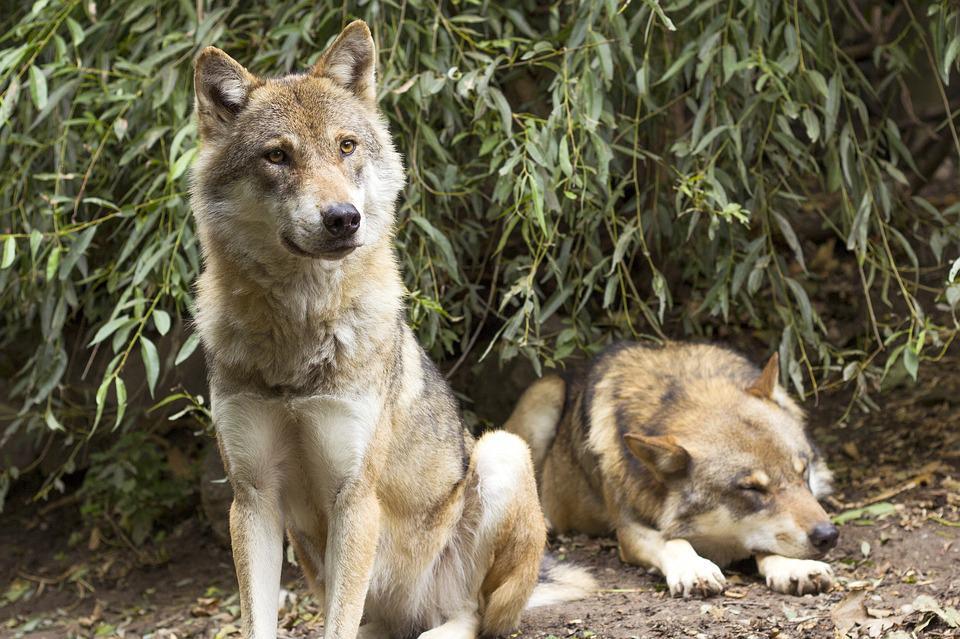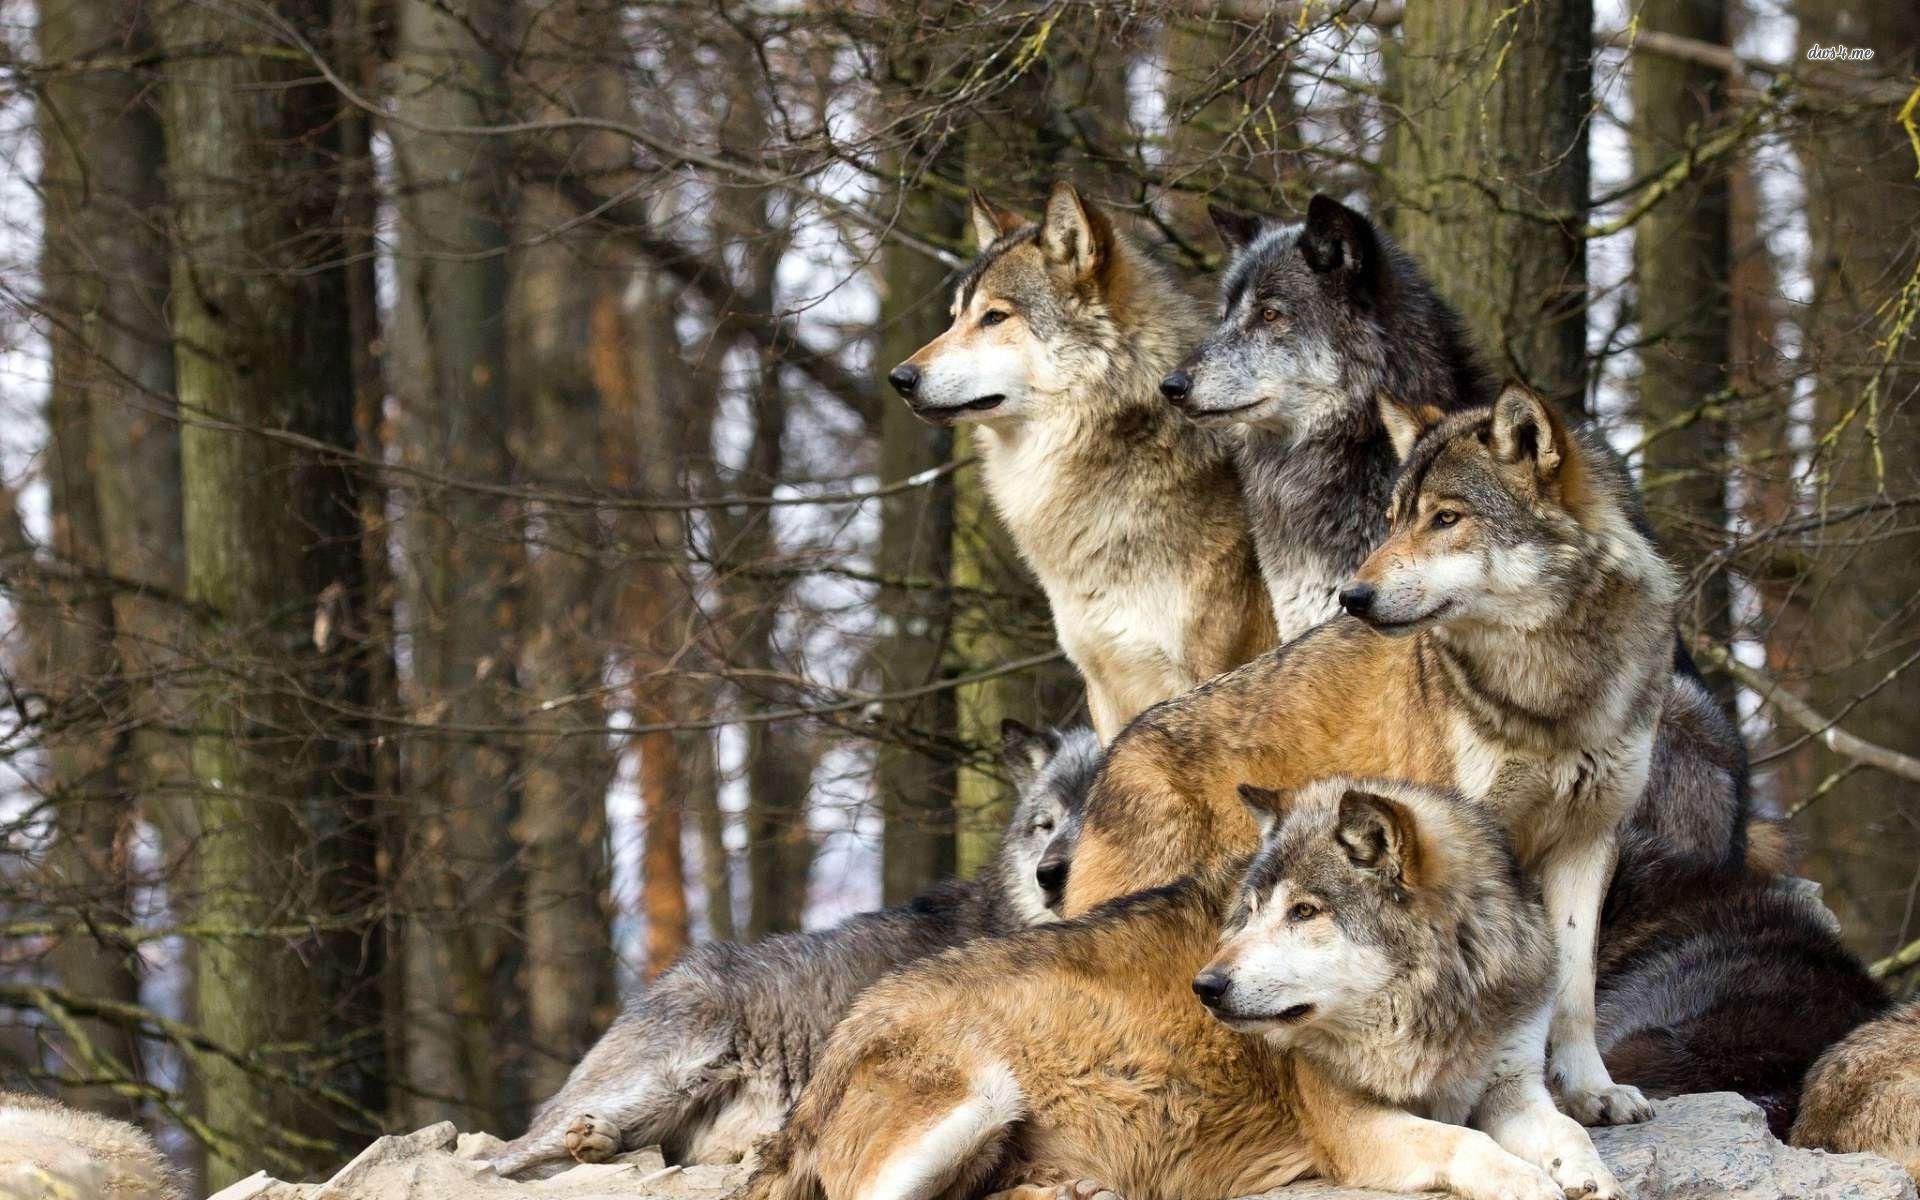The first image is the image on the left, the second image is the image on the right. Examine the images to the left and right. Is the description "In only one of the two images do all the animals appear to be focused on the same thing." accurate? Answer yes or no. Yes. The first image is the image on the left, the second image is the image on the right. Evaluate the accuracy of this statement regarding the images: "The wolves are in the snow in only one of the images.". Is it true? Answer yes or no. No. 